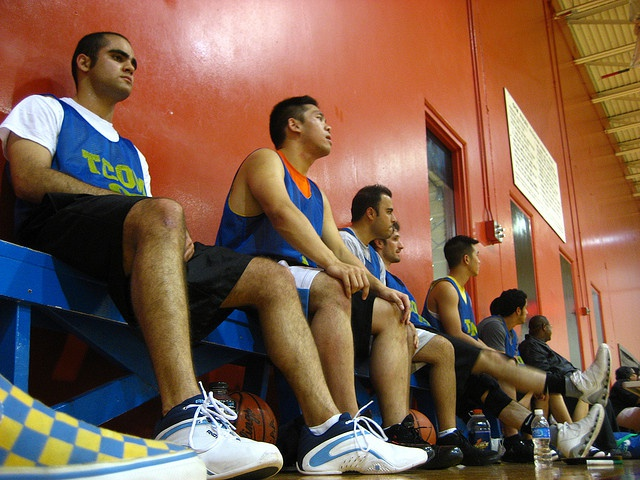Describe the objects in this image and their specific colors. I can see people in brown, black, olive, tan, and maroon tones, people in brown, black, tan, maroon, and olive tones, bench in brown, black, navy, blue, and darkblue tones, people in brown, black, olive, darkgray, and tan tones, and people in brown, ivory, khaki, and gray tones in this image. 